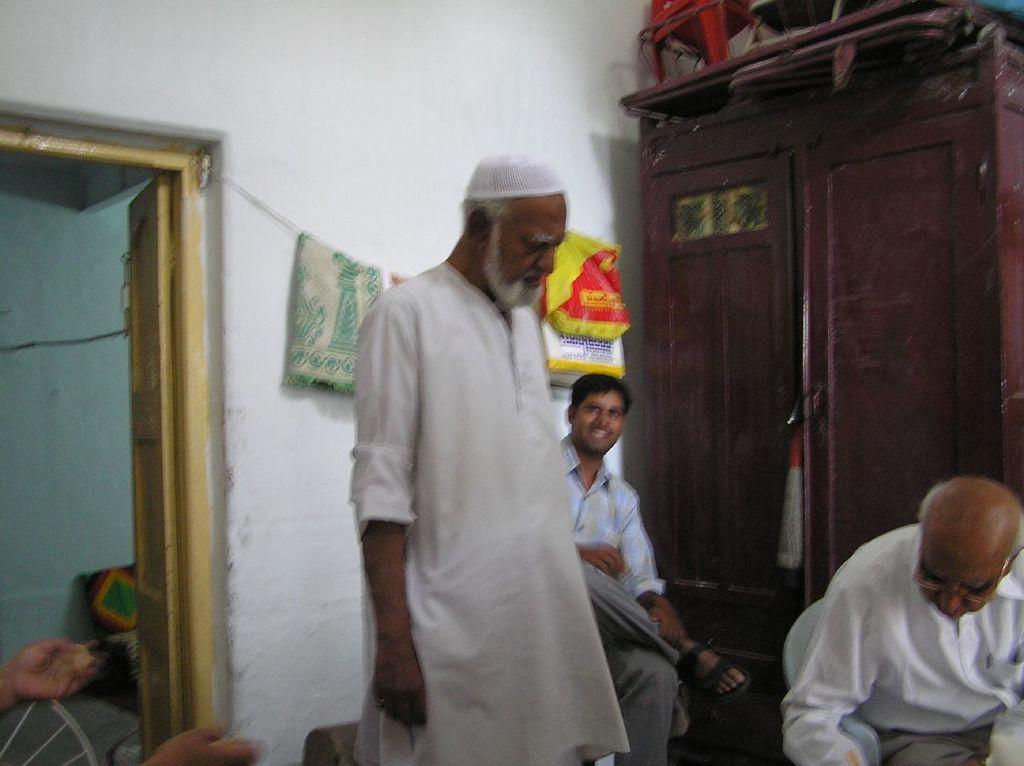How many people are present in the image? There is a person standing and two persons are sitting on chairs, so there are three people in the image. What is the person standing doing? The facts do not specify what the person standing is doing. What is on the cupboard in the image? There are objects on the cupboard. What type of furniture is visible in the image? There are chairs, a cupboard, and a door in the image. What is covering some of the objects in the image? There are covers visible in the image. What is the background of the image made of? The wall is visible in the background of the image. What type of soup is being served in the image? There is no soup present in the image. What is the beggar doing in the image? There is no beggar present in the image. 